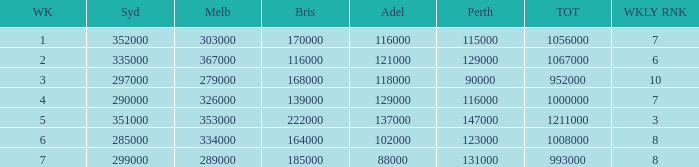How many episodes aired in Sydney in Week 3? 1.0. 